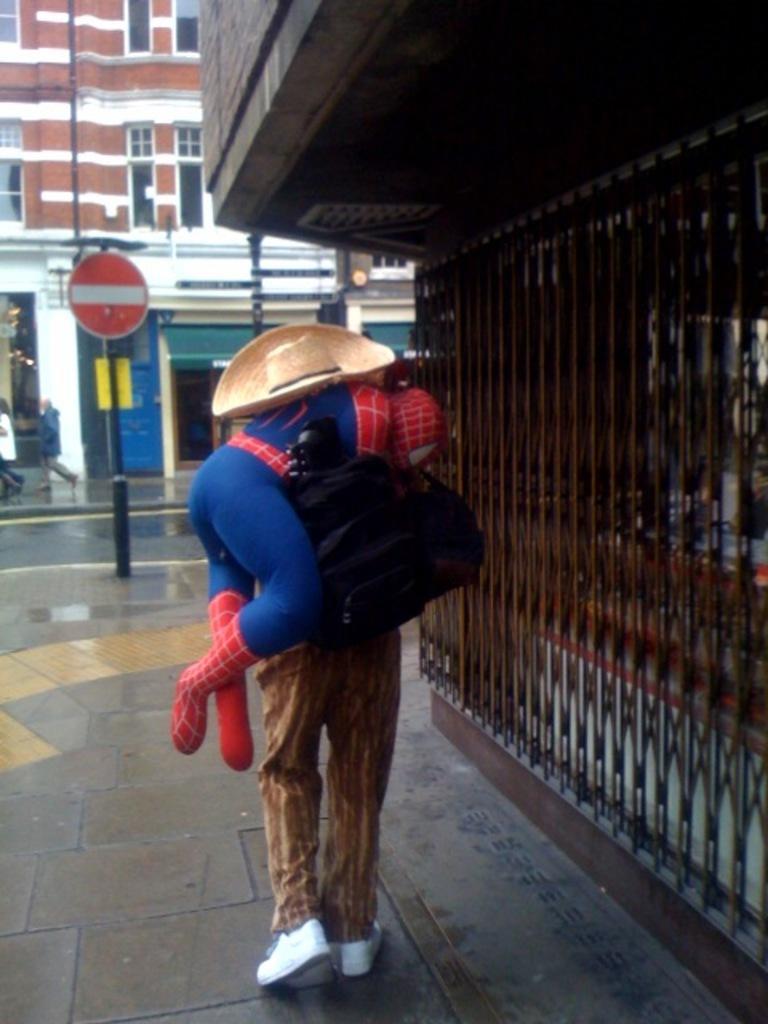Could you give a brief overview of what you see in this image? In the center of the image we can see a person standing and holding another person. On the right there is a grille. In the background there is a building and we can see a stop board. There are people walking. 